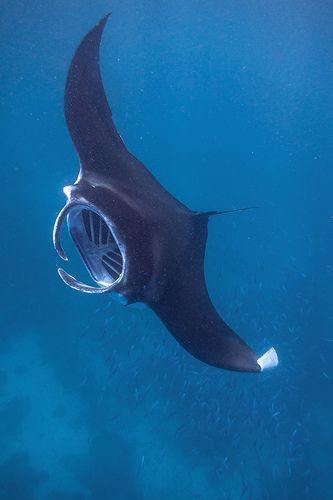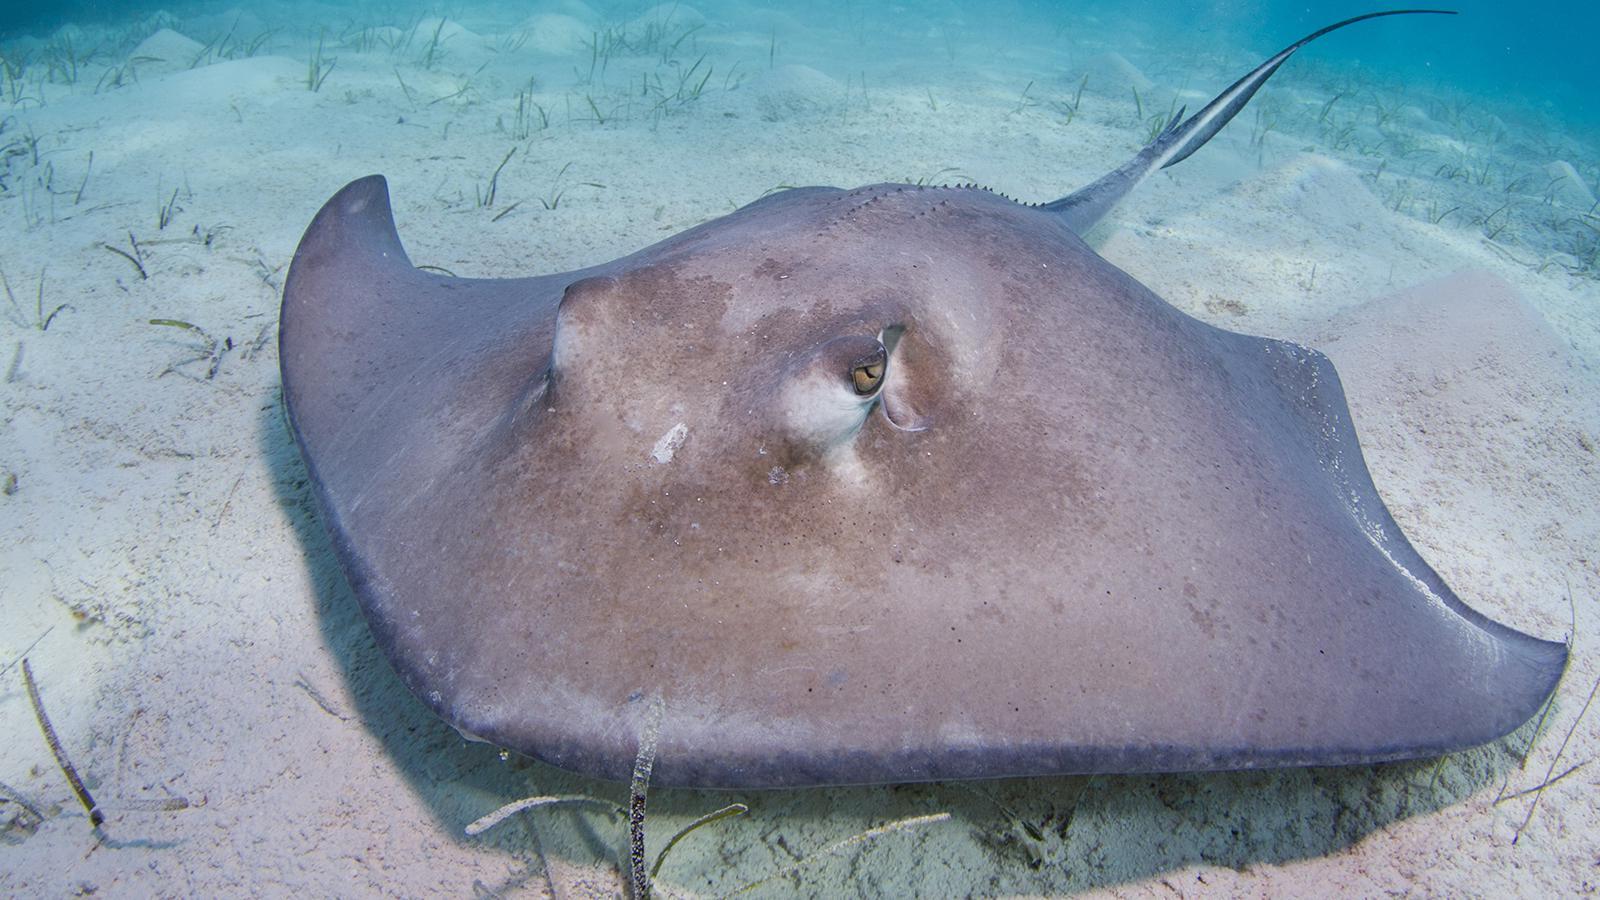The first image is the image on the left, the second image is the image on the right. Analyze the images presented: Is the assertion "The animal in the image on the left is just above the seafloor." valid? Answer yes or no. No. 